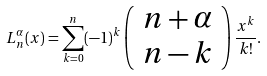Convert formula to latex. <formula><loc_0><loc_0><loc_500><loc_500>L _ { n } ^ { \alpha } ( x ) = \sum _ { k = 0 } ^ { n } ( - 1 ) ^ { k } \left ( \begin{array} { c } n + \alpha \\ n - k \end{array} \right ) \frac { x ^ { k } } { k ! } .</formula> 